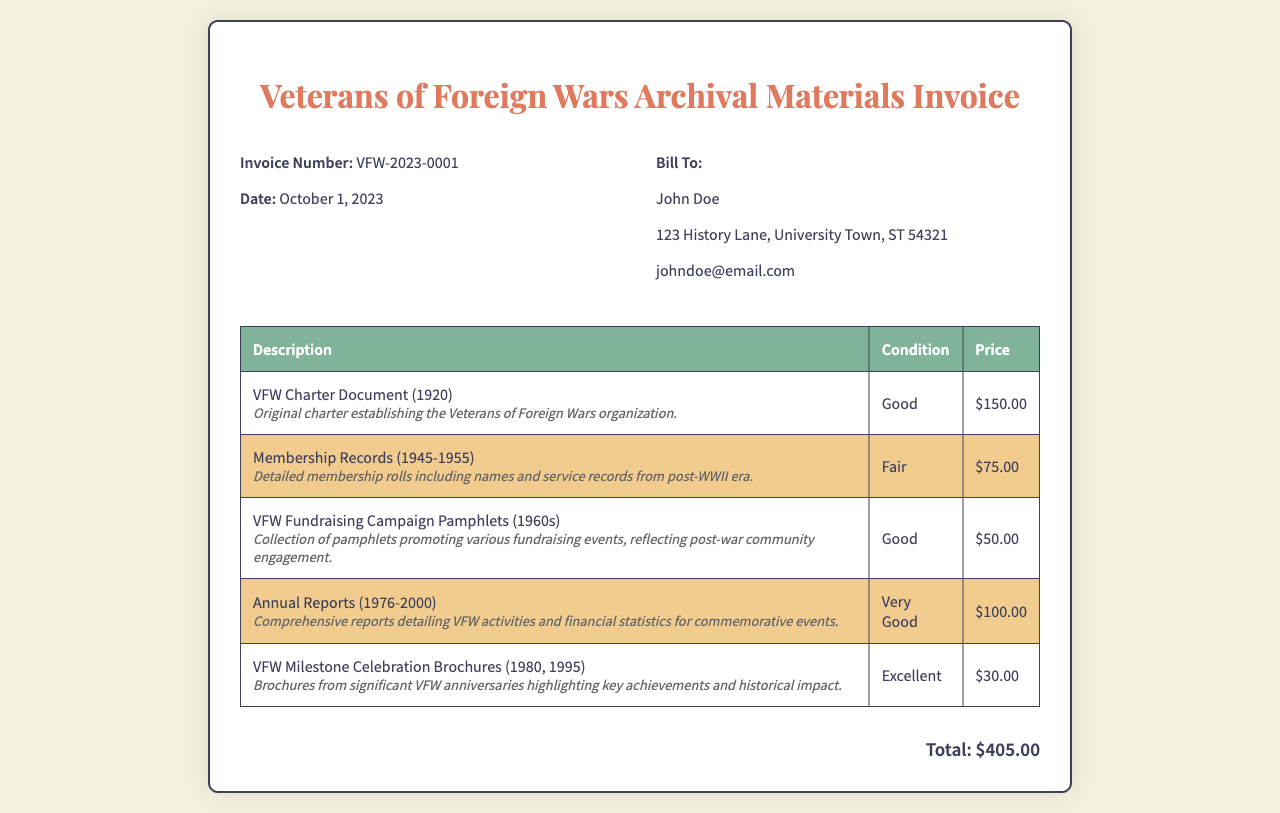what is the invoice number? The invoice number is a unique identifier for this document, found in the invoice details section.
Answer: VFW-2023-0001 what is the date of the invoice? The date indicates when the invoice was created, which is relevant for payment and record-keeping.
Answer: October 1, 2023 who is the invoice billed to? The billed entity shows the recipient of the invoice, which is important for verifying the purchaser.
Answer: John Doe how many items are listed in the invoice? This counts all individual entries in the table, providing an overview of the number of materials purchased.
Answer: 5 what is the total amount due? The total amount due is the sum of all items listed, providing the final amount that must be paid.
Answer: $405.00 which document has the condition 'Fair'? This identifies the specific item condition, which helps in understanding the quality of the archival materials.
Answer: Membership Records (1945-1955) what is the price of the VFW Charter Document? This is a specific detail about one of the items listed, critical for budgeting decisions.
Answer: $150.00 which item is the oldest document listed? This question requires identifying the document's date, linking it to its historical significance.
Answer: VFW Charter Document (1920) how many Annual Reports are covered in the invoice? This asks about the range of documents and their significance to the organization’s history.
Answer: 25 years (1976-2000) 